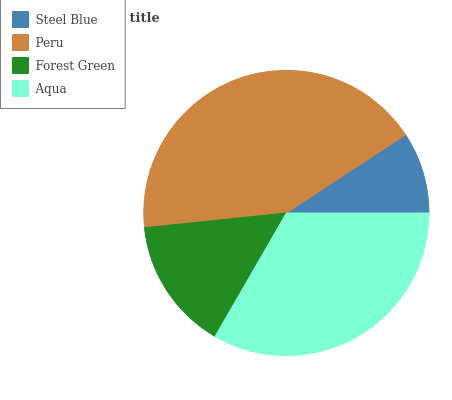Is Steel Blue the minimum?
Answer yes or no. Yes. Is Peru the maximum?
Answer yes or no. Yes. Is Forest Green the minimum?
Answer yes or no. No. Is Forest Green the maximum?
Answer yes or no. No. Is Peru greater than Forest Green?
Answer yes or no. Yes. Is Forest Green less than Peru?
Answer yes or no. Yes. Is Forest Green greater than Peru?
Answer yes or no. No. Is Peru less than Forest Green?
Answer yes or no. No. Is Aqua the high median?
Answer yes or no. Yes. Is Forest Green the low median?
Answer yes or no. Yes. Is Peru the high median?
Answer yes or no. No. Is Peru the low median?
Answer yes or no. No. 